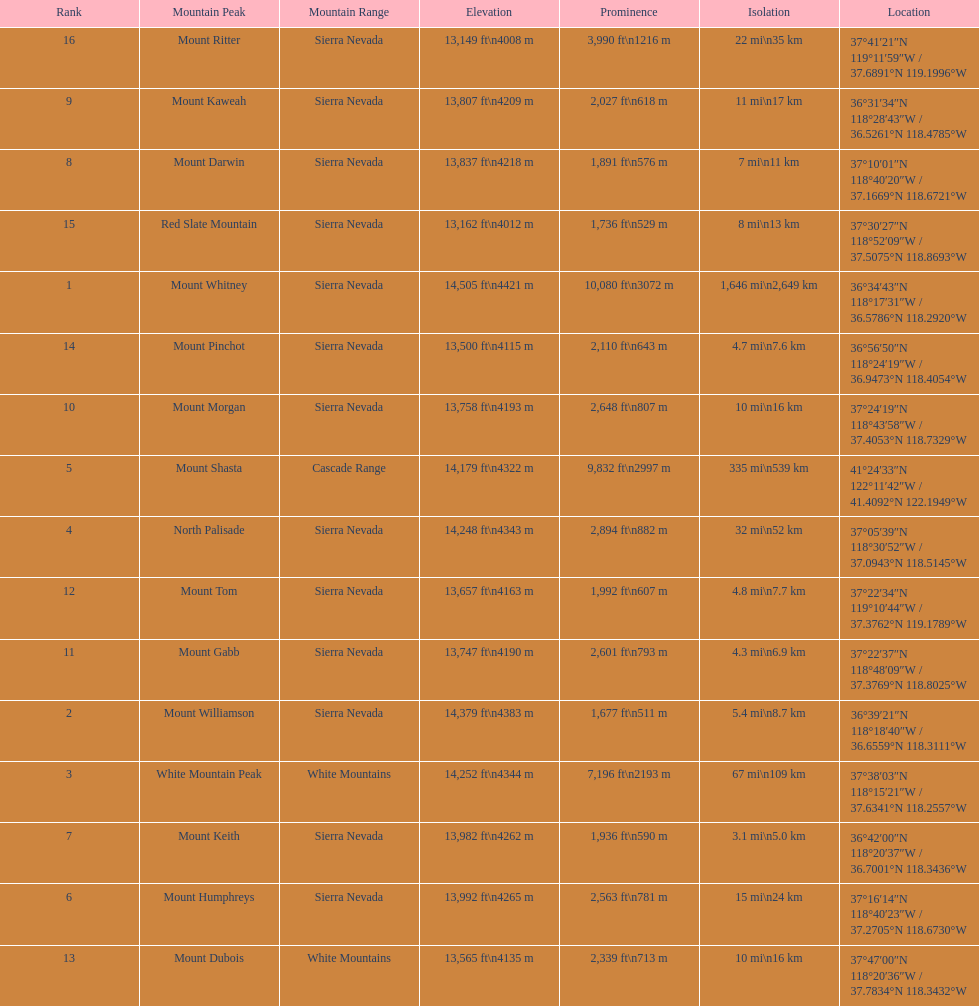What is the only mountain peak listed for the cascade range? Mount Shasta. 